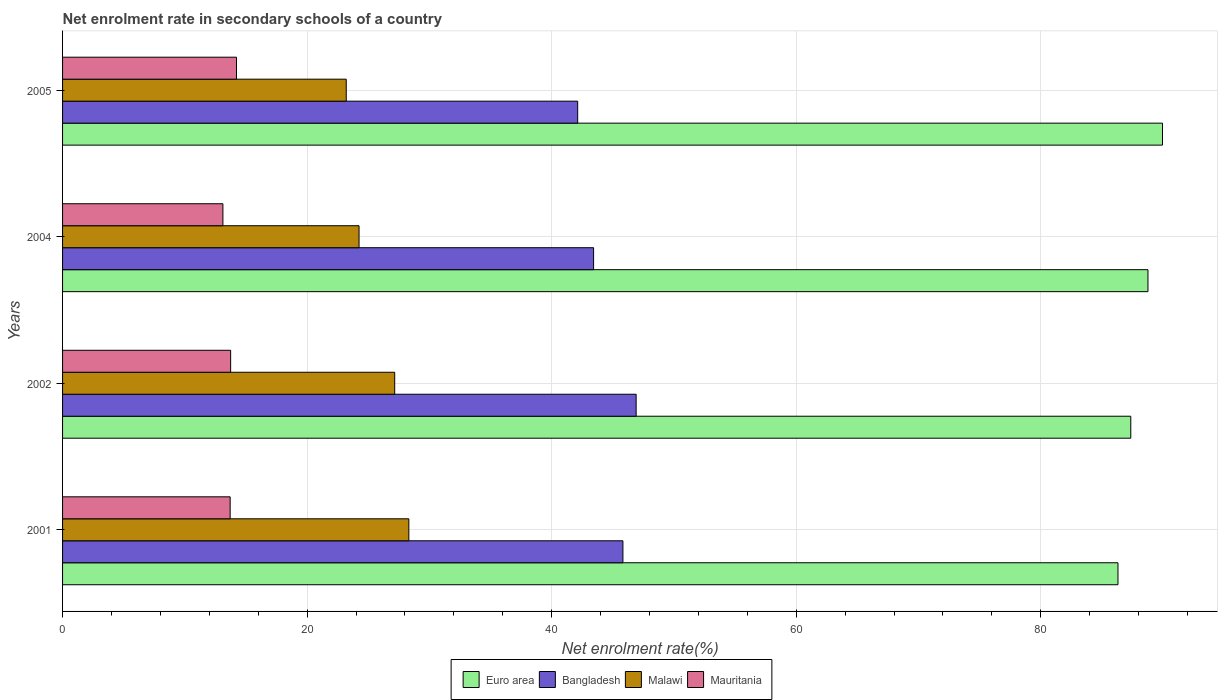How many groups of bars are there?
Give a very brief answer. 4. Are the number of bars per tick equal to the number of legend labels?
Give a very brief answer. Yes. How many bars are there on the 3rd tick from the bottom?
Ensure brevity in your answer.  4. What is the label of the 2nd group of bars from the top?
Ensure brevity in your answer.  2004. In how many cases, is the number of bars for a given year not equal to the number of legend labels?
Give a very brief answer. 0. What is the net enrolment rate in secondary schools in Mauritania in 2004?
Your answer should be very brief. 13.11. Across all years, what is the maximum net enrolment rate in secondary schools in Euro area?
Your answer should be compact. 89.96. Across all years, what is the minimum net enrolment rate in secondary schools in Euro area?
Your response must be concise. 86.32. What is the total net enrolment rate in secondary schools in Euro area in the graph?
Your answer should be compact. 352.41. What is the difference between the net enrolment rate in secondary schools in Malawi in 2001 and that in 2002?
Provide a succinct answer. 1.16. What is the difference between the net enrolment rate in secondary schools in Mauritania in 2004 and the net enrolment rate in secondary schools in Euro area in 2005?
Provide a short and direct response. -76.84. What is the average net enrolment rate in secondary schools in Euro area per year?
Make the answer very short. 88.1. In the year 2001, what is the difference between the net enrolment rate in secondary schools in Euro area and net enrolment rate in secondary schools in Mauritania?
Ensure brevity in your answer.  72.61. In how many years, is the net enrolment rate in secondary schools in Malawi greater than 12 %?
Provide a short and direct response. 4. What is the ratio of the net enrolment rate in secondary schools in Malawi in 2001 to that in 2005?
Your response must be concise. 1.22. Is the difference between the net enrolment rate in secondary schools in Euro area in 2004 and 2005 greater than the difference between the net enrolment rate in secondary schools in Mauritania in 2004 and 2005?
Make the answer very short. No. What is the difference between the highest and the second highest net enrolment rate in secondary schools in Mauritania?
Your response must be concise. 0.48. What is the difference between the highest and the lowest net enrolment rate in secondary schools in Mauritania?
Your answer should be very brief. 1.11. In how many years, is the net enrolment rate in secondary schools in Euro area greater than the average net enrolment rate in secondary schools in Euro area taken over all years?
Your answer should be compact. 2. Is the sum of the net enrolment rate in secondary schools in Bangladesh in 2001 and 2005 greater than the maximum net enrolment rate in secondary schools in Malawi across all years?
Ensure brevity in your answer.  Yes. What does the 2nd bar from the bottom in 2004 represents?
Offer a very short reply. Bangladesh. Is it the case that in every year, the sum of the net enrolment rate in secondary schools in Mauritania and net enrolment rate in secondary schools in Euro area is greater than the net enrolment rate in secondary schools in Bangladesh?
Provide a succinct answer. Yes. How many bars are there?
Give a very brief answer. 16. How many years are there in the graph?
Your answer should be very brief. 4. What is the difference between two consecutive major ticks on the X-axis?
Provide a succinct answer. 20. Does the graph contain any zero values?
Ensure brevity in your answer.  No. Does the graph contain grids?
Ensure brevity in your answer.  Yes. Where does the legend appear in the graph?
Your answer should be compact. Bottom center. What is the title of the graph?
Your answer should be very brief. Net enrolment rate in secondary schools of a country. Does "Uganda" appear as one of the legend labels in the graph?
Your answer should be very brief. No. What is the label or title of the X-axis?
Your response must be concise. Net enrolment rate(%). What is the label or title of the Y-axis?
Offer a very short reply. Years. What is the Net enrolment rate(%) in Euro area in 2001?
Your answer should be very brief. 86.32. What is the Net enrolment rate(%) of Bangladesh in 2001?
Offer a very short reply. 45.83. What is the Net enrolment rate(%) of Malawi in 2001?
Provide a succinct answer. 28.32. What is the Net enrolment rate(%) of Mauritania in 2001?
Your answer should be very brief. 13.71. What is the Net enrolment rate(%) in Euro area in 2002?
Give a very brief answer. 87.36. What is the Net enrolment rate(%) in Bangladesh in 2002?
Your answer should be very brief. 46.91. What is the Net enrolment rate(%) in Malawi in 2002?
Ensure brevity in your answer.  27.16. What is the Net enrolment rate(%) of Mauritania in 2002?
Give a very brief answer. 13.75. What is the Net enrolment rate(%) in Euro area in 2004?
Your answer should be compact. 88.77. What is the Net enrolment rate(%) in Bangladesh in 2004?
Offer a terse response. 43.43. What is the Net enrolment rate(%) in Malawi in 2004?
Your answer should be compact. 24.25. What is the Net enrolment rate(%) of Mauritania in 2004?
Offer a terse response. 13.11. What is the Net enrolment rate(%) in Euro area in 2005?
Provide a succinct answer. 89.96. What is the Net enrolment rate(%) in Bangladesh in 2005?
Your answer should be compact. 42.13. What is the Net enrolment rate(%) of Malawi in 2005?
Make the answer very short. 23.2. What is the Net enrolment rate(%) in Mauritania in 2005?
Your answer should be compact. 14.23. Across all years, what is the maximum Net enrolment rate(%) in Euro area?
Offer a very short reply. 89.96. Across all years, what is the maximum Net enrolment rate(%) of Bangladesh?
Ensure brevity in your answer.  46.91. Across all years, what is the maximum Net enrolment rate(%) in Malawi?
Ensure brevity in your answer.  28.32. Across all years, what is the maximum Net enrolment rate(%) of Mauritania?
Keep it short and to the point. 14.23. Across all years, what is the minimum Net enrolment rate(%) in Euro area?
Keep it short and to the point. 86.32. Across all years, what is the minimum Net enrolment rate(%) of Bangladesh?
Your answer should be very brief. 42.13. Across all years, what is the minimum Net enrolment rate(%) in Malawi?
Provide a short and direct response. 23.2. Across all years, what is the minimum Net enrolment rate(%) in Mauritania?
Make the answer very short. 13.11. What is the total Net enrolment rate(%) of Euro area in the graph?
Your answer should be compact. 352.41. What is the total Net enrolment rate(%) of Bangladesh in the graph?
Offer a terse response. 178.3. What is the total Net enrolment rate(%) of Malawi in the graph?
Keep it short and to the point. 102.93. What is the total Net enrolment rate(%) of Mauritania in the graph?
Your answer should be compact. 54.79. What is the difference between the Net enrolment rate(%) of Euro area in 2001 and that in 2002?
Your response must be concise. -1.05. What is the difference between the Net enrolment rate(%) of Bangladesh in 2001 and that in 2002?
Make the answer very short. -1.08. What is the difference between the Net enrolment rate(%) of Malawi in 2001 and that in 2002?
Offer a terse response. 1.16. What is the difference between the Net enrolment rate(%) of Mauritania in 2001 and that in 2002?
Your answer should be compact. -0.04. What is the difference between the Net enrolment rate(%) of Euro area in 2001 and that in 2004?
Give a very brief answer. -2.45. What is the difference between the Net enrolment rate(%) in Bangladesh in 2001 and that in 2004?
Provide a short and direct response. 2.4. What is the difference between the Net enrolment rate(%) in Malawi in 2001 and that in 2004?
Make the answer very short. 4.07. What is the difference between the Net enrolment rate(%) in Mauritania in 2001 and that in 2004?
Your response must be concise. 0.59. What is the difference between the Net enrolment rate(%) in Euro area in 2001 and that in 2005?
Provide a short and direct response. -3.64. What is the difference between the Net enrolment rate(%) of Bangladesh in 2001 and that in 2005?
Your response must be concise. 3.7. What is the difference between the Net enrolment rate(%) in Malawi in 2001 and that in 2005?
Offer a very short reply. 5.12. What is the difference between the Net enrolment rate(%) of Mauritania in 2001 and that in 2005?
Provide a short and direct response. -0.52. What is the difference between the Net enrolment rate(%) of Euro area in 2002 and that in 2004?
Give a very brief answer. -1.41. What is the difference between the Net enrolment rate(%) in Bangladesh in 2002 and that in 2004?
Your answer should be very brief. 3.48. What is the difference between the Net enrolment rate(%) of Malawi in 2002 and that in 2004?
Provide a succinct answer. 2.92. What is the difference between the Net enrolment rate(%) in Mauritania in 2002 and that in 2004?
Give a very brief answer. 0.63. What is the difference between the Net enrolment rate(%) of Euro area in 2002 and that in 2005?
Make the answer very short. -2.59. What is the difference between the Net enrolment rate(%) in Bangladesh in 2002 and that in 2005?
Your response must be concise. 4.78. What is the difference between the Net enrolment rate(%) in Malawi in 2002 and that in 2005?
Offer a very short reply. 3.96. What is the difference between the Net enrolment rate(%) in Mauritania in 2002 and that in 2005?
Offer a very short reply. -0.48. What is the difference between the Net enrolment rate(%) of Euro area in 2004 and that in 2005?
Give a very brief answer. -1.19. What is the difference between the Net enrolment rate(%) in Bangladesh in 2004 and that in 2005?
Your answer should be compact. 1.3. What is the difference between the Net enrolment rate(%) in Malawi in 2004 and that in 2005?
Offer a very short reply. 1.05. What is the difference between the Net enrolment rate(%) in Mauritania in 2004 and that in 2005?
Make the answer very short. -1.11. What is the difference between the Net enrolment rate(%) in Euro area in 2001 and the Net enrolment rate(%) in Bangladesh in 2002?
Offer a terse response. 39.41. What is the difference between the Net enrolment rate(%) of Euro area in 2001 and the Net enrolment rate(%) of Malawi in 2002?
Offer a terse response. 59.15. What is the difference between the Net enrolment rate(%) of Euro area in 2001 and the Net enrolment rate(%) of Mauritania in 2002?
Offer a very short reply. 72.57. What is the difference between the Net enrolment rate(%) of Bangladesh in 2001 and the Net enrolment rate(%) of Malawi in 2002?
Provide a short and direct response. 18.66. What is the difference between the Net enrolment rate(%) in Bangladesh in 2001 and the Net enrolment rate(%) in Mauritania in 2002?
Provide a short and direct response. 32.08. What is the difference between the Net enrolment rate(%) of Malawi in 2001 and the Net enrolment rate(%) of Mauritania in 2002?
Give a very brief answer. 14.57. What is the difference between the Net enrolment rate(%) in Euro area in 2001 and the Net enrolment rate(%) in Bangladesh in 2004?
Ensure brevity in your answer.  42.89. What is the difference between the Net enrolment rate(%) of Euro area in 2001 and the Net enrolment rate(%) of Malawi in 2004?
Make the answer very short. 62.07. What is the difference between the Net enrolment rate(%) in Euro area in 2001 and the Net enrolment rate(%) in Mauritania in 2004?
Offer a terse response. 73.2. What is the difference between the Net enrolment rate(%) in Bangladesh in 2001 and the Net enrolment rate(%) in Malawi in 2004?
Give a very brief answer. 21.58. What is the difference between the Net enrolment rate(%) of Bangladesh in 2001 and the Net enrolment rate(%) of Mauritania in 2004?
Keep it short and to the point. 32.72. What is the difference between the Net enrolment rate(%) of Malawi in 2001 and the Net enrolment rate(%) of Mauritania in 2004?
Keep it short and to the point. 15.21. What is the difference between the Net enrolment rate(%) of Euro area in 2001 and the Net enrolment rate(%) of Bangladesh in 2005?
Keep it short and to the point. 44.19. What is the difference between the Net enrolment rate(%) of Euro area in 2001 and the Net enrolment rate(%) of Malawi in 2005?
Make the answer very short. 63.12. What is the difference between the Net enrolment rate(%) in Euro area in 2001 and the Net enrolment rate(%) in Mauritania in 2005?
Your answer should be very brief. 72.09. What is the difference between the Net enrolment rate(%) of Bangladesh in 2001 and the Net enrolment rate(%) of Malawi in 2005?
Offer a terse response. 22.63. What is the difference between the Net enrolment rate(%) of Bangladesh in 2001 and the Net enrolment rate(%) of Mauritania in 2005?
Your answer should be compact. 31.6. What is the difference between the Net enrolment rate(%) of Malawi in 2001 and the Net enrolment rate(%) of Mauritania in 2005?
Ensure brevity in your answer.  14.1. What is the difference between the Net enrolment rate(%) in Euro area in 2002 and the Net enrolment rate(%) in Bangladesh in 2004?
Ensure brevity in your answer.  43.93. What is the difference between the Net enrolment rate(%) of Euro area in 2002 and the Net enrolment rate(%) of Malawi in 2004?
Your response must be concise. 63.12. What is the difference between the Net enrolment rate(%) in Euro area in 2002 and the Net enrolment rate(%) in Mauritania in 2004?
Give a very brief answer. 74.25. What is the difference between the Net enrolment rate(%) in Bangladesh in 2002 and the Net enrolment rate(%) in Malawi in 2004?
Offer a terse response. 22.66. What is the difference between the Net enrolment rate(%) of Bangladesh in 2002 and the Net enrolment rate(%) of Mauritania in 2004?
Offer a terse response. 33.8. What is the difference between the Net enrolment rate(%) of Malawi in 2002 and the Net enrolment rate(%) of Mauritania in 2004?
Your answer should be compact. 14.05. What is the difference between the Net enrolment rate(%) in Euro area in 2002 and the Net enrolment rate(%) in Bangladesh in 2005?
Your response must be concise. 45.23. What is the difference between the Net enrolment rate(%) of Euro area in 2002 and the Net enrolment rate(%) of Malawi in 2005?
Provide a succinct answer. 64.16. What is the difference between the Net enrolment rate(%) in Euro area in 2002 and the Net enrolment rate(%) in Mauritania in 2005?
Ensure brevity in your answer.  73.14. What is the difference between the Net enrolment rate(%) of Bangladesh in 2002 and the Net enrolment rate(%) of Malawi in 2005?
Provide a succinct answer. 23.71. What is the difference between the Net enrolment rate(%) of Bangladesh in 2002 and the Net enrolment rate(%) of Mauritania in 2005?
Make the answer very short. 32.68. What is the difference between the Net enrolment rate(%) of Malawi in 2002 and the Net enrolment rate(%) of Mauritania in 2005?
Your answer should be very brief. 12.94. What is the difference between the Net enrolment rate(%) of Euro area in 2004 and the Net enrolment rate(%) of Bangladesh in 2005?
Offer a terse response. 46.64. What is the difference between the Net enrolment rate(%) of Euro area in 2004 and the Net enrolment rate(%) of Malawi in 2005?
Ensure brevity in your answer.  65.57. What is the difference between the Net enrolment rate(%) in Euro area in 2004 and the Net enrolment rate(%) in Mauritania in 2005?
Your response must be concise. 74.54. What is the difference between the Net enrolment rate(%) of Bangladesh in 2004 and the Net enrolment rate(%) of Malawi in 2005?
Your answer should be very brief. 20.23. What is the difference between the Net enrolment rate(%) in Bangladesh in 2004 and the Net enrolment rate(%) in Mauritania in 2005?
Your response must be concise. 29.2. What is the difference between the Net enrolment rate(%) of Malawi in 2004 and the Net enrolment rate(%) of Mauritania in 2005?
Offer a terse response. 10.02. What is the average Net enrolment rate(%) in Euro area per year?
Keep it short and to the point. 88.1. What is the average Net enrolment rate(%) in Bangladesh per year?
Give a very brief answer. 44.57. What is the average Net enrolment rate(%) in Malawi per year?
Provide a short and direct response. 25.73. What is the average Net enrolment rate(%) of Mauritania per year?
Provide a short and direct response. 13.7. In the year 2001, what is the difference between the Net enrolment rate(%) of Euro area and Net enrolment rate(%) of Bangladesh?
Your response must be concise. 40.49. In the year 2001, what is the difference between the Net enrolment rate(%) in Euro area and Net enrolment rate(%) in Malawi?
Your response must be concise. 58. In the year 2001, what is the difference between the Net enrolment rate(%) in Euro area and Net enrolment rate(%) in Mauritania?
Provide a succinct answer. 72.61. In the year 2001, what is the difference between the Net enrolment rate(%) in Bangladesh and Net enrolment rate(%) in Malawi?
Provide a short and direct response. 17.51. In the year 2001, what is the difference between the Net enrolment rate(%) of Bangladesh and Net enrolment rate(%) of Mauritania?
Your response must be concise. 32.12. In the year 2001, what is the difference between the Net enrolment rate(%) in Malawi and Net enrolment rate(%) in Mauritania?
Provide a succinct answer. 14.61. In the year 2002, what is the difference between the Net enrolment rate(%) of Euro area and Net enrolment rate(%) of Bangladesh?
Your answer should be compact. 40.45. In the year 2002, what is the difference between the Net enrolment rate(%) in Euro area and Net enrolment rate(%) in Malawi?
Keep it short and to the point. 60.2. In the year 2002, what is the difference between the Net enrolment rate(%) in Euro area and Net enrolment rate(%) in Mauritania?
Provide a succinct answer. 73.62. In the year 2002, what is the difference between the Net enrolment rate(%) in Bangladesh and Net enrolment rate(%) in Malawi?
Give a very brief answer. 19.75. In the year 2002, what is the difference between the Net enrolment rate(%) of Bangladesh and Net enrolment rate(%) of Mauritania?
Keep it short and to the point. 33.16. In the year 2002, what is the difference between the Net enrolment rate(%) of Malawi and Net enrolment rate(%) of Mauritania?
Ensure brevity in your answer.  13.42. In the year 2004, what is the difference between the Net enrolment rate(%) of Euro area and Net enrolment rate(%) of Bangladesh?
Keep it short and to the point. 45.34. In the year 2004, what is the difference between the Net enrolment rate(%) in Euro area and Net enrolment rate(%) in Malawi?
Provide a short and direct response. 64.52. In the year 2004, what is the difference between the Net enrolment rate(%) in Euro area and Net enrolment rate(%) in Mauritania?
Your answer should be very brief. 75.66. In the year 2004, what is the difference between the Net enrolment rate(%) of Bangladesh and Net enrolment rate(%) of Malawi?
Offer a terse response. 19.18. In the year 2004, what is the difference between the Net enrolment rate(%) of Bangladesh and Net enrolment rate(%) of Mauritania?
Provide a succinct answer. 30.32. In the year 2004, what is the difference between the Net enrolment rate(%) in Malawi and Net enrolment rate(%) in Mauritania?
Your answer should be very brief. 11.13. In the year 2005, what is the difference between the Net enrolment rate(%) in Euro area and Net enrolment rate(%) in Bangladesh?
Offer a terse response. 47.83. In the year 2005, what is the difference between the Net enrolment rate(%) in Euro area and Net enrolment rate(%) in Malawi?
Your answer should be very brief. 66.76. In the year 2005, what is the difference between the Net enrolment rate(%) in Euro area and Net enrolment rate(%) in Mauritania?
Keep it short and to the point. 75.73. In the year 2005, what is the difference between the Net enrolment rate(%) of Bangladesh and Net enrolment rate(%) of Malawi?
Your answer should be very brief. 18.93. In the year 2005, what is the difference between the Net enrolment rate(%) of Bangladesh and Net enrolment rate(%) of Mauritania?
Give a very brief answer. 27.9. In the year 2005, what is the difference between the Net enrolment rate(%) of Malawi and Net enrolment rate(%) of Mauritania?
Keep it short and to the point. 8.97. What is the ratio of the Net enrolment rate(%) in Euro area in 2001 to that in 2002?
Your answer should be very brief. 0.99. What is the ratio of the Net enrolment rate(%) in Bangladesh in 2001 to that in 2002?
Your answer should be compact. 0.98. What is the ratio of the Net enrolment rate(%) in Malawi in 2001 to that in 2002?
Your response must be concise. 1.04. What is the ratio of the Net enrolment rate(%) in Mauritania in 2001 to that in 2002?
Your answer should be very brief. 1. What is the ratio of the Net enrolment rate(%) of Euro area in 2001 to that in 2004?
Offer a very short reply. 0.97. What is the ratio of the Net enrolment rate(%) of Bangladesh in 2001 to that in 2004?
Provide a short and direct response. 1.06. What is the ratio of the Net enrolment rate(%) in Malawi in 2001 to that in 2004?
Your response must be concise. 1.17. What is the ratio of the Net enrolment rate(%) of Mauritania in 2001 to that in 2004?
Provide a succinct answer. 1.05. What is the ratio of the Net enrolment rate(%) in Euro area in 2001 to that in 2005?
Ensure brevity in your answer.  0.96. What is the ratio of the Net enrolment rate(%) of Bangladesh in 2001 to that in 2005?
Your answer should be very brief. 1.09. What is the ratio of the Net enrolment rate(%) in Malawi in 2001 to that in 2005?
Ensure brevity in your answer.  1.22. What is the ratio of the Net enrolment rate(%) in Mauritania in 2001 to that in 2005?
Provide a succinct answer. 0.96. What is the ratio of the Net enrolment rate(%) of Euro area in 2002 to that in 2004?
Your response must be concise. 0.98. What is the ratio of the Net enrolment rate(%) in Bangladesh in 2002 to that in 2004?
Provide a short and direct response. 1.08. What is the ratio of the Net enrolment rate(%) in Malawi in 2002 to that in 2004?
Offer a very short reply. 1.12. What is the ratio of the Net enrolment rate(%) in Mauritania in 2002 to that in 2004?
Provide a succinct answer. 1.05. What is the ratio of the Net enrolment rate(%) of Euro area in 2002 to that in 2005?
Your answer should be compact. 0.97. What is the ratio of the Net enrolment rate(%) in Bangladesh in 2002 to that in 2005?
Your answer should be very brief. 1.11. What is the ratio of the Net enrolment rate(%) of Malawi in 2002 to that in 2005?
Give a very brief answer. 1.17. What is the ratio of the Net enrolment rate(%) in Mauritania in 2002 to that in 2005?
Provide a short and direct response. 0.97. What is the ratio of the Net enrolment rate(%) of Bangladesh in 2004 to that in 2005?
Provide a short and direct response. 1.03. What is the ratio of the Net enrolment rate(%) in Malawi in 2004 to that in 2005?
Your answer should be very brief. 1.05. What is the ratio of the Net enrolment rate(%) of Mauritania in 2004 to that in 2005?
Provide a succinct answer. 0.92. What is the difference between the highest and the second highest Net enrolment rate(%) of Euro area?
Your answer should be compact. 1.19. What is the difference between the highest and the second highest Net enrolment rate(%) of Bangladesh?
Keep it short and to the point. 1.08. What is the difference between the highest and the second highest Net enrolment rate(%) of Malawi?
Provide a short and direct response. 1.16. What is the difference between the highest and the second highest Net enrolment rate(%) of Mauritania?
Your response must be concise. 0.48. What is the difference between the highest and the lowest Net enrolment rate(%) of Euro area?
Offer a very short reply. 3.64. What is the difference between the highest and the lowest Net enrolment rate(%) in Bangladesh?
Offer a very short reply. 4.78. What is the difference between the highest and the lowest Net enrolment rate(%) of Malawi?
Offer a very short reply. 5.12. What is the difference between the highest and the lowest Net enrolment rate(%) of Mauritania?
Your response must be concise. 1.11. 